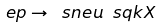<formula> <loc_0><loc_0><loc_500><loc_500>e p \to \ s n e u \ s q k X</formula> 